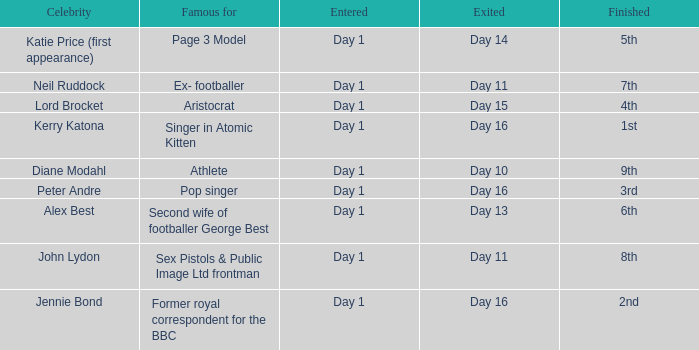Name who was famous for finished in 9th Athlete. 